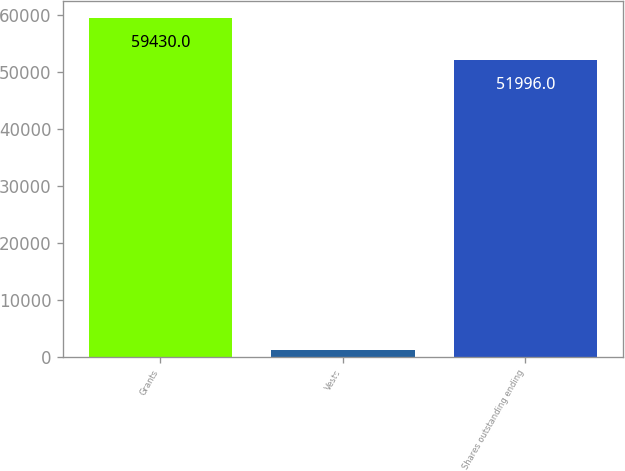Convert chart to OTSL. <chart><loc_0><loc_0><loc_500><loc_500><bar_chart><fcel>Grants<fcel>Vests<fcel>Shares outstanding ending<nl><fcel>59430<fcel>1262<fcel>51996<nl></chart> 